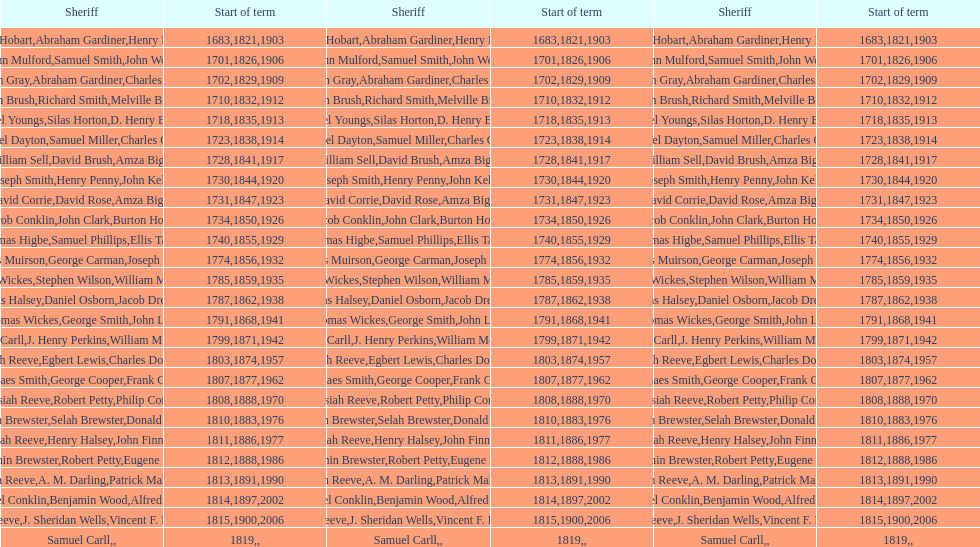How many sheriffs, in total, have there been in suffolk county? 76. 